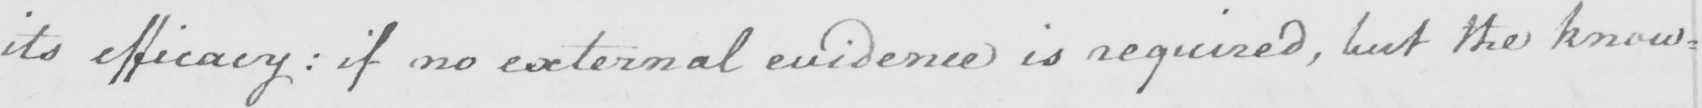What is written in this line of handwriting? its efficacy :  if no external evidence is required , but the know= 